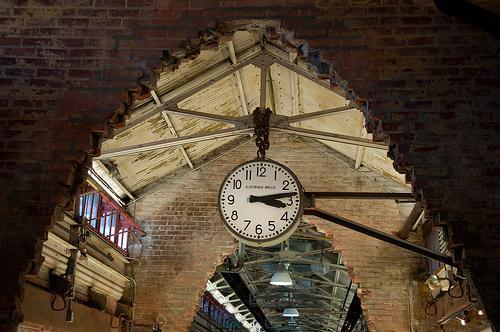How many hanging lamps are behind the clock?
Give a very brief answer. 2. 